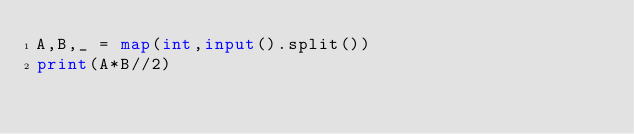Convert code to text. <code><loc_0><loc_0><loc_500><loc_500><_Python_>A,B,_ = map(int,input().split())
print(A*B//2)</code> 